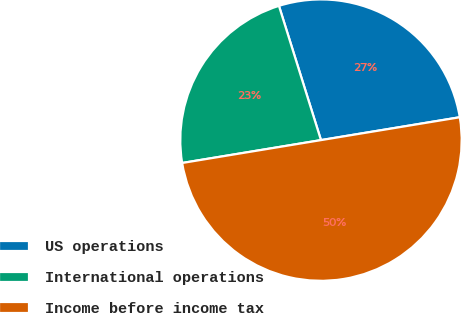Convert chart. <chart><loc_0><loc_0><loc_500><loc_500><pie_chart><fcel>US operations<fcel>International operations<fcel>Income before income tax<nl><fcel>27.23%<fcel>22.77%<fcel>50.0%<nl></chart> 